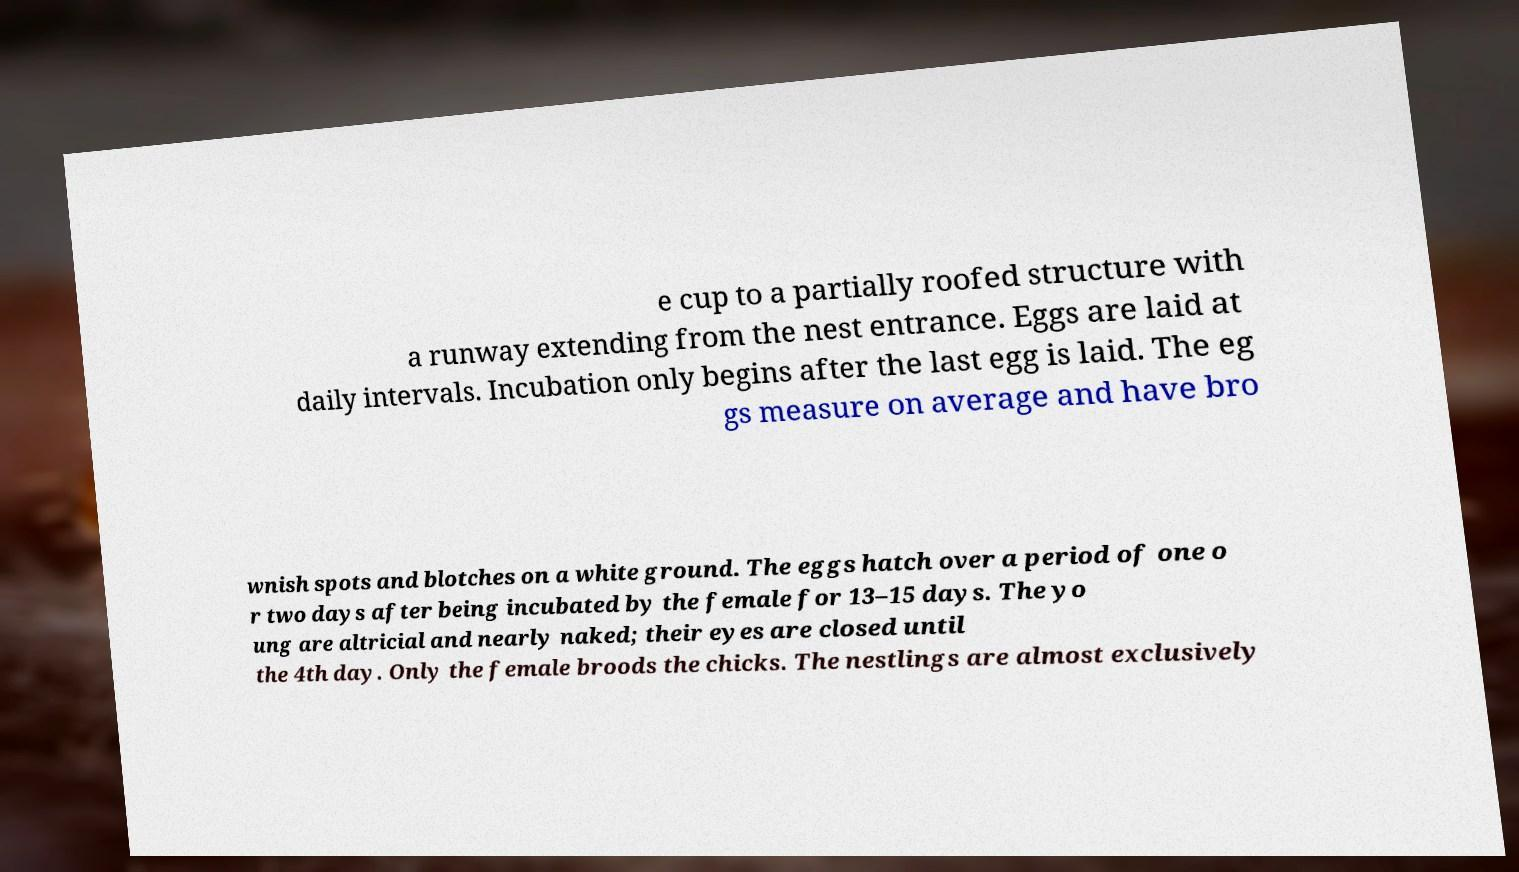For documentation purposes, I need the text within this image transcribed. Could you provide that? e cup to a partially roofed structure with a runway extending from the nest entrance. Eggs are laid at daily intervals. Incubation only begins after the last egg is laid. The eg gs measure on average and have bro wnish spots and blotches on a white ground. The eggs hatch over a period of one o r two days after being incubated by the female for 13–15 days. The yo ung are altricial and nearly naked; their eyes are closed until the 4th day. Only the female broods the chicks. The nestlings are almost exclusively 